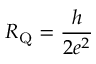Convert formula to latex. <formula><loc_0><loc_0><loc_500><loc_500>R _ { Q } = \frac { h } { 2 e ^ { 2 } }</formula> 